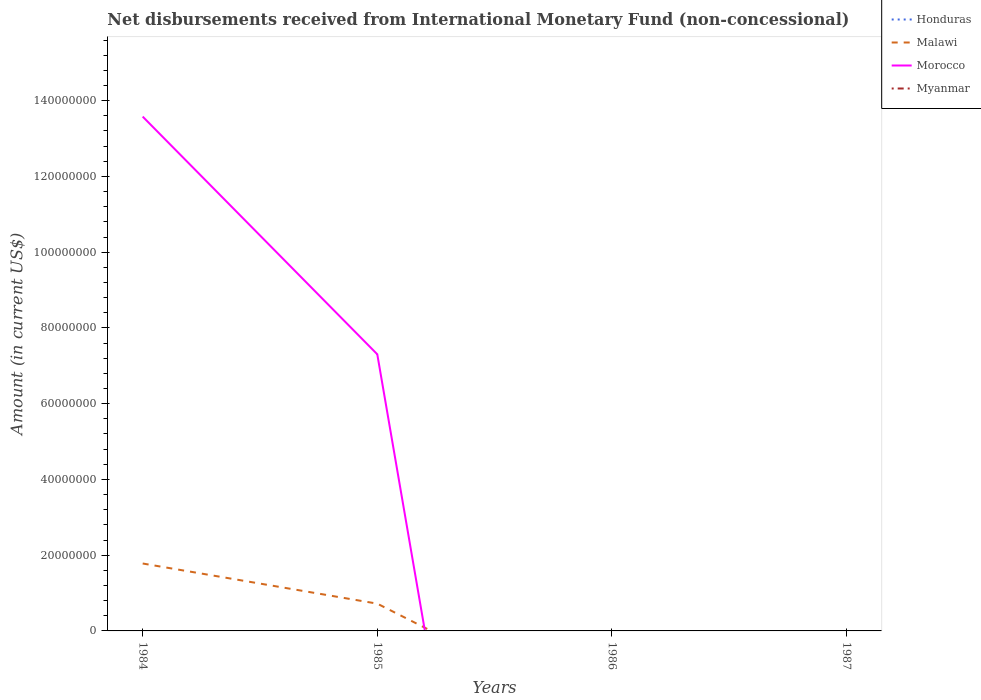How many different coloured lines are there?
Make the answer very short. 2. Is the number of lines equal to the number of legend labels?
Keep it short and to the point. No. Across all years, what is the maximum amount of disbursements received from International Monetary Fund in Malawi?
Your answer should be very brief. 0. What is the difference between the highest and the second highest amount of disbursements received from International Monetary Fund in Morocco?
Your answer should be compact. 1.36e+08. Is the amount of disbursements received from International Monetary Fund in Honduras strictly greater than the amount of disbursements received from International Monetary Fund in Morocco over the years?
Your response must be concise. No. How many lines are there?
Offer a very short reply. 2. Where does the legend appear in the graph?
Offer a terse response. Top right. How many legend labels are there?
Ensure brevity in your answer.  4. How are the legend labels stacked?
Offer a terse response. Vertical. What is the title of the graph?
Provide a short and direct response. Net disbursements received from International Monetary Fund (non-concessional). Does "Venezuela" appear as one of the legend labels in the graph?
Ensure brevity in your answer.  No. What is the label or title of the Y-axis?
Make the answer very short. Amount (in current US$). What is the Amount (in current US$) in Honduras in 1984?
Offer a terse response. 0. What is the Amount (in current US$) of Malawi in 1984?
Provide a succinct answer. 1.78e+07. What is the Amount (in current US$) of Morocco in 1984?
Offer a very short reply. 1.36e+08. What is the Amount (in current US$) in Malawi in 1985?
Your answer should be very brief. 7.20e+06. What is the Amount (in current US$) in Morocco in 1985?
Offer a very short reply. 7.30e+07. What is the Amount (in current US$) in Morocco in 1986?
Your response must be concise. 0. What is the Amount (in current US$) in Myanmar in 1986?
Offer a terse response. 0. What is the Amount (in current US$) of Morocco in 1987?
Offer a very short reply. 0. What is the Amount (in current US$) in Myanmar in 1987?
Your answer should be compact. 0. Across all years, what is the maximum Amount (in current US$) of Malawi?
Keep it short and to the point. 1.78e+07. Across all years, what is the maximum Amount (in current US$) in Morocco?
Offer a very short reply. 1.36e+08. Across all years, what is the minimum Amount (in current US$) in Malawi?
Offer a terse response. 0. What is the total Amount (in current US$) of Malawi in the graph?
Make the answer very short. 2.50e+07. What is the total Amount (in current US$) of Morocco in the graph?
Offer a terse response. 2.09e+08. What is the difference between the Amount (in current US$) of Malawi in 1984 and that in 1985?
Give a very brief answer. 1.06e+07. What is the difference between the Amount (in current US$) in Morocco in 1984 and that in 1985?
Your answer should be compact. 6.28e+07. What is the difference between the Amount (in current US$) of Malawi in 1984 and the Amount (in current US$) of Morocco in 1985?
Give a very brief answer. -5.52e+07. What is the average Amount (in current US$) of Malawi per year?
Your response must be concise. 6.25e+06. What is the average Amount (in current US$) of Morocco per year?
Ensure brevity in your answer.  5.22e+07. In the year 1984, what is the difference between the Amount (in current US$) in Malawi and Amount (in current US$) in Morocco?
Offer a very short reply. -1.18e+08. In the year 1985, what is the difference between the Amount (in current US$) in Malawi and Amount (in current US$) in Morocco?
Ensure brevity in your answer.  -6.58e+07. What is the ratio of the Amount (in current US$) in Malawi in 1984 to that in 1985?
Keep it short and to the point. 2.47. What is the ratio of the Amount (in current US$) of Morocco in 1984 to that in 1985?
Your answer should be very brief. 1.86. What is the difference between the highest and the lowest Amount (in current US$) of Malawi?
Keep it short and to the point. 1.78e+07. What is the difference between the highest and the lowest Amount (in current US$) in Morocco?
Your response must be concise. 1.36e+08. 